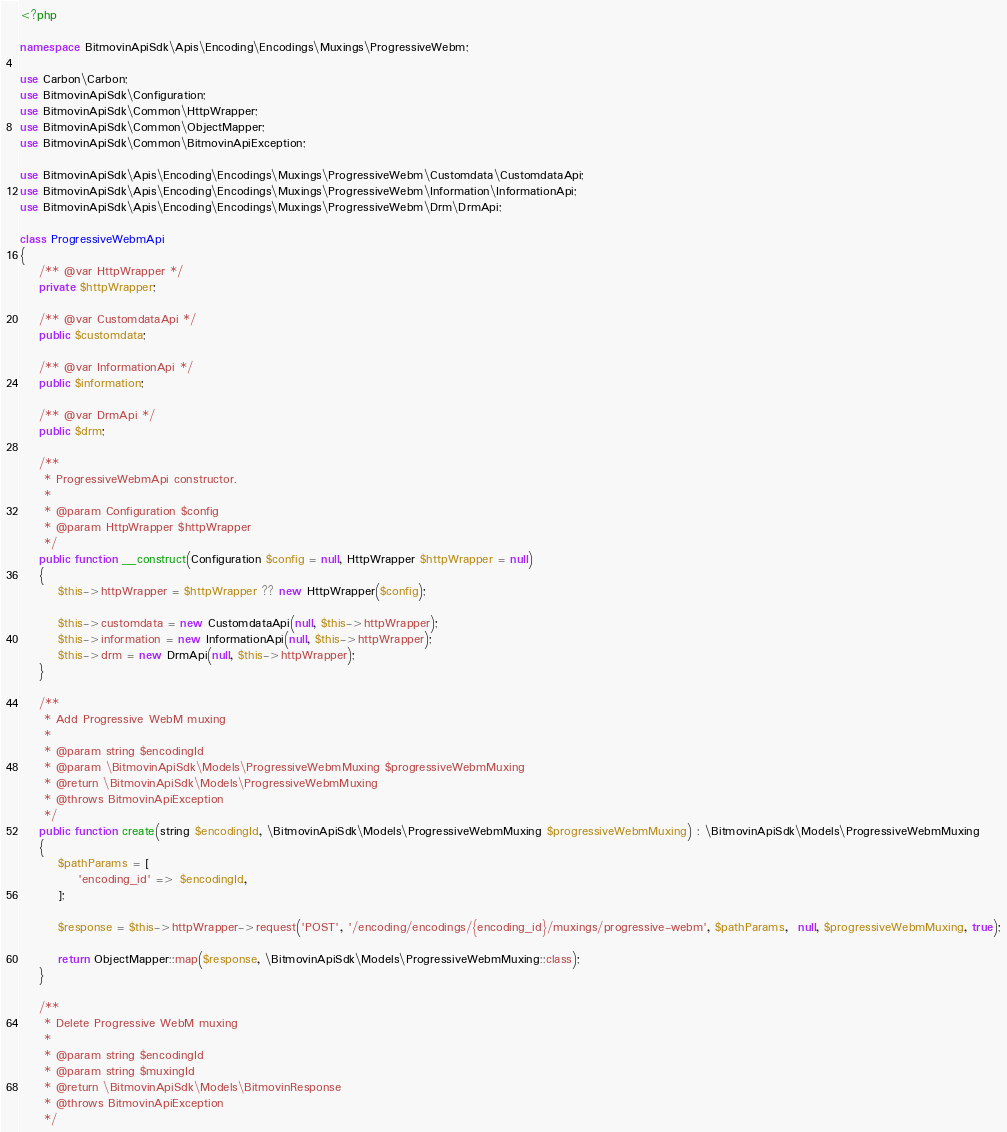<code> <loc_0><loc_0><loc_500><loc_500><_PHP_><?php

namespace BitmovinApiSdk\Apis\Encoding\Encodings\Muxings\ProgressiveWebm;

use Carbon\Carbon;
use BitmovinApiSdk\Configuration;
use BitmovinApiSdk\Common\HttpWrapper;
use BitmovinApiSdk\Common\ObjectMapper;
use BitmovinApiSdk\Common\BitmovinApiException;

use BitmovinApiSdk\Apis\Encoding\Encodings\Muxings\ProgressiveWebm\Customdata\CustomdataApi;
use BitmovinApiSdk\Apis\Encoding\Encodings\Muxings\ProgressiveWebm\Information\InformationApi;
use BitmovinApiSdk\Apis\Encoding\Encodings\Muxings\ProgressiveWebm\Drm\DrmApi;

class ProgressiveWebmApi
{
    /** @var HttpWrapper */
    private $httpWrapper;

    /** @var CustomdataApi */
    public $customdata;

    /** @var InformationApi */
    public $information;

    /** @var DrmApi */
    public $drm;

    /**
     * ProgressiveWebmApi constructor.
     *
     * @param Configuration $config
     * @param HttpWrapper $httpWrapper
     */
    public function __construct(Configuration $config = null, HttpWrapper $httpWrapper = null)
    {
        $this->httpWrapper = $httpWrapper ?? new HttpWrapper($config);

        $this->customdata = new CustomdataApi(null, $this->httpWrapper);
        $this->information = new InformationApi(null, $this->httpWrapper);
        $this->drm = new DrmApi(null, $this->httpWrapper);
    }

    /**
     * Add Progressive WebM muxing
     *
     * @param string $encodingId
     * @param \BitmovinApiSdk\Models\ProgressiveWebmMuxing $progressiveWebmMuxing
     * @return \BitmovinApiSdk\Models\ProgressiveWebmMuxing
     * @throws BitmovinApiException
     */
    public function create(string $encodingId, \BitmovinApiSdk\Models\ProgressiveWebmMuxing $progressiveWebmMuxing) : \BitmovinApiSdk\Models\ProgressiveWebmMuxing
    {
        $pathParams = [
            'encoding_id' => $encodingId,
        ];

        $response = $this->httpWrapper->request('POST', '/encoding/encodings/{encoding_id}/muxings/progressive-webm', $pathParams,  null, $progressiveWebmMuxing, true);

        return ObjectMapper::map($response, \BitmovinApiSdk\Models\ProgressiveWebmMuxing::class);
    }

    /**
     * Delete Progressive WebM muxing
     *
     * @param string $encodingId
     * @param string $muxingId
     * @return \BitmovinApiSdk\Models\BitmovinResponse
     * @throws BitmovinApiException
     */</code> 